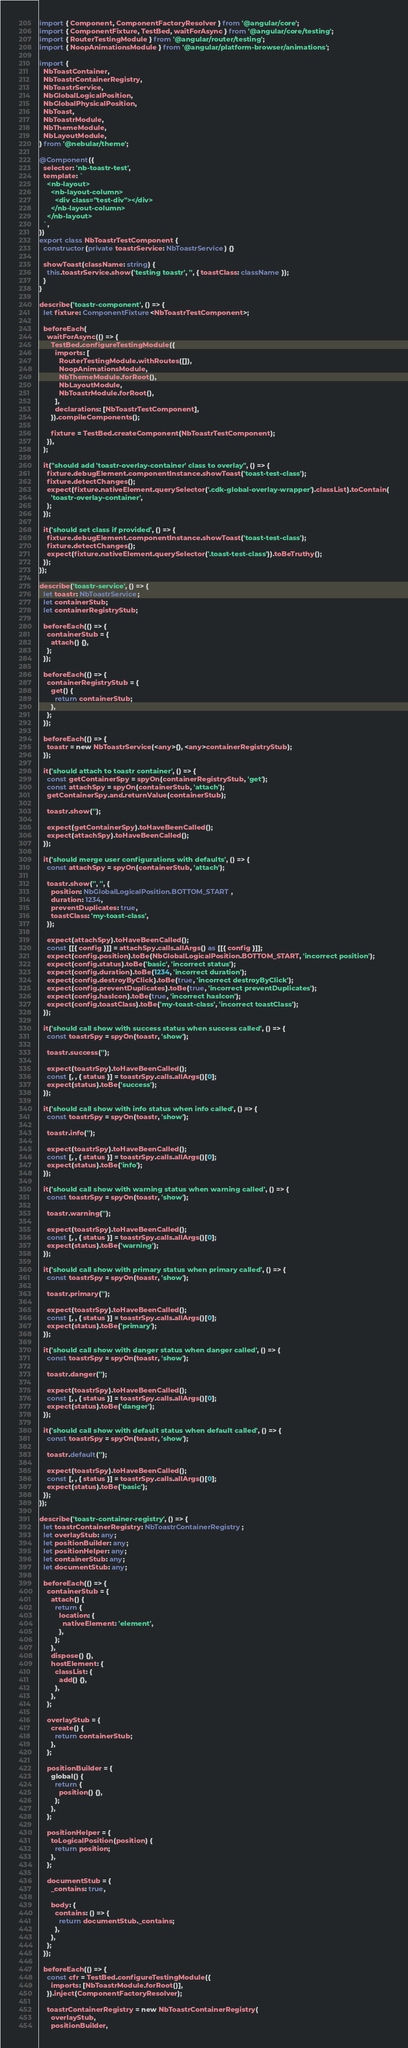Convert code to text. <code><loc_0><loc_0><loc_500><loc_500><_TypeScript_>import { Component, ComponentFactoryResolver } from '@angular/core';
import { ComponentFixture, TestBed, waitForAsync } from '@angular/core/testing';
import { RouterTestingModule } from '@angular/router/testing';
import { NoopAnimationsModule } from '@angular/platform-browser/animations';

import {
  NbToastContainer,
  NbToastrContainerRegistry,
  NbToastrService,
  NbGlobalLogicalPosition,
  NbGlobalPhysicalPosition,
  NbToast,
  NbToastrModule,
  NbThemeModule,
  NbLayoutModule,
} from '@nebular/theme';

@Component({
  selector: 'nb-toastr-test',
  template: `
    <nb-layout>
      <nb-layout-column>
        <div class="test-div"></div>
      </nb-layout-column>
    </nb-layout>
  `,
})
export class NbToastrTestComponent {
  constructor(private toastrService: NbToastrService) {}

  showToast(className: string) {
    this.toastrService.show('testing toastr', '', { toastClass: className });
  }
}

describe('toastr-component', () => {
  let fixture: ComponentFixture<NbToastrTestComponent>;

  beforeEach(
    waitForAsync(() => {
      TestBed.configureTestingModule({
        imports: [
          RouterTestingModule.withRoutes([]),
          NoopAnimationsModule,
          NbThemeModule.forRoot(),
          NbLayoutModule,
          NbToastrModule.forRoot(),
        ],
        declarations: [NbToastrTestComponent],
      }).compileComponents();

      fixture = TestBed.createComponent(NbToastrTestComponent);
    }),
  );

  it("should add 'toastr-overlay-container' class to overlay", () => {
    fixture.debugElement.componentInstance.showToast('toast-test-class');
    fixture.detectChanges();
    expect(fixture.nativeElement.querySelector('.cdk-global-overlay-wrapper').classList).toContain(
      'toastr-overlay-container',
    );
  });

  it('should set class if provided', () => {
    fixture.debugElement.componentInstance.showToast('toast-test-class');
    fixture.detectChanges();
    expect(fixture.nativeElement.querySelector('.toast-test-class')).toBeTruthy();
  });
});

describe('toastr-service', () => {
  let toastr: NbToastrService;
  let containerStub;
  let containerRegistryStub;

  beforeEach(() => {
    containerStub = {
      attach() {},
    };
  });

  beforeEach(() => {
    containerRegistryStub = {
      get() {
        return containerStub;
      },
    };
  });

  beforeEach(() => {
    toastr = new NbToastrService(<any>{}, <any>containerRegistryStub);
  });

  it('should attach to toastr container', () => {
    const getContainerSpy = spyOn(containerRegistryStub, 'get');
    const attachSpy = spyOn(containerStub, 'attach');
    getContainerSpy.and.returnValue(containerStub);

    toastr.show('');

    expect(getContainerSpy).toHaveBeenCalled();
    expect(attachSpy).toHaveBeenCalled();
  });

  it('should merge user configurations with defaults', () => {
    const attachSpy = spyOn(containerStub, 'attach');

    toastr.show('', '', {
      position: NbGlobalLogicalPosition.BOTTOM_START,
      duration: 1234,
      preventDuplicates: true,
      toastClass: 'my-toast-class',
    });

    expect(attachSpy).toHaveBeenCalled();
    const [[{ config }]] = attachSpy.calls.allArgs() as [[{ config }]];
    expect(config.position).toBe(NbGlobalLogicalPosition.BOTTOM_START, 'incorrect position');
    expect(config.status).toBe('basic', 'incorrect status');
    expect(config.duration).toBe(1234, 'incorrect duration');
    expect(config.destroyByClick).toBe(true, 'incorrect destroyByClick');
    expect(config.preventDuplicates).toBe(true, 'incorrect preventDuplicates');
    expect(config.hasIcon).toBe(true, 'incorrect hasIcon');
    expect(config.toastClass).toBe('my-toast-class', 'incorrect toastClass');
  });

  it('should call show with success status when success called', () => {
    const toastrSpy = spyOn(toastr, 'show');

    toastr.success('');

    expect(toastrSpy).toHaveBeenCalled();
    const [, , { status }] = toastrSpy.calls.allArgs()[0];
    expect(status).toBe('success');
  });

  it('should call show with info status when info called', () => {
    const toastrSpy = spyOn(toastr, 'show');

    toastr.info('');

    expect(toastrSpy).toHaveBeenCalled();
    const [, , { status }] = toastrSpy.calls.allArgs()[0];
    expect(status).toBe('info');
  });

  it('should call show with warning status when warning called', () => {
    const toastrSpy = spyOn(toastr, 'show');

    toastr.warning('');

    expect(toastrSpy).toHaveBeenCalled();
    const [, , { status }] = toastrSpy.calls.allArgs()[0];
    expect(status).toBe('warning');
  });

  it('should call show with primary status when primary called', () => {
    const toastrSpy = spyOn(toastr, 'show');

    toastr.primary('');

    expect(toastrSpy).toHaveBeenCalled();
    const [, , { status }] = toastrSpy.calls.allArgs()[0];
    expect(status).toBe('primary');
  });

  it('should call show with danger status when danger called', () => {
    const toastrSpy = spyOn(toastr, 'show');

    toastr.danger('');

    expect(toastrSpy).toHaveBeenCalled();
    const [, , { status }] = toastrSpy.calls.allArgs()[0];
    expect(status).toBe('danger');
  });

  it('should call show with default status when default called', () => {
    const toastrSpy = spyOn(toastr, 'show');

    toastr.default('');

    expect(toastrSpy).toHaveBeenCalled();
    const [, , { status }] = toastrSpy.calls.allArgs()[0];
    expect(status).toBe('basic');
  });
});

describe('toastr-container-registry', () => {
  let toastrContainerRegistry: NbToastrContainerRegistry;
  let overlayStub: any;
  let positionBuilder: any;
  let positionHelper: any;
  let containerStub: any;
  let documentStub: any;

  beforeEach(() => {
    containerStub = {
      attach() {
        return {
          location: {
            nativeElement: 'element',
          },
        };
      },
      dispose() {},
      hostElement: {
        classList: {
          add() {},
        },
      },
    };

    overlayStub = {
      create() {
        return containerStub;
      },
    };

    positionBuilder = {
      global() {
        return {
          position() {},
        };
      },
    };

    positionHelper = {
      toLogicalPosition(position) {
        return position;
      },
    };

    documentStub = {
      _contains: true,

      body: {
        contains: () => {
          return documentStub._contains;
        },
      },
    };
  });

  beforeEach(() => {
    const cfr = TestBed.configureTestingModule({
      imports: [NbToastrModule.forRoot()],
    }).inject(ComponentFactoryResolver);

    toastrContainerRegistry = new NbToastrContainerRegistry(
      overlayStub,
      positionBuilder,</code> 